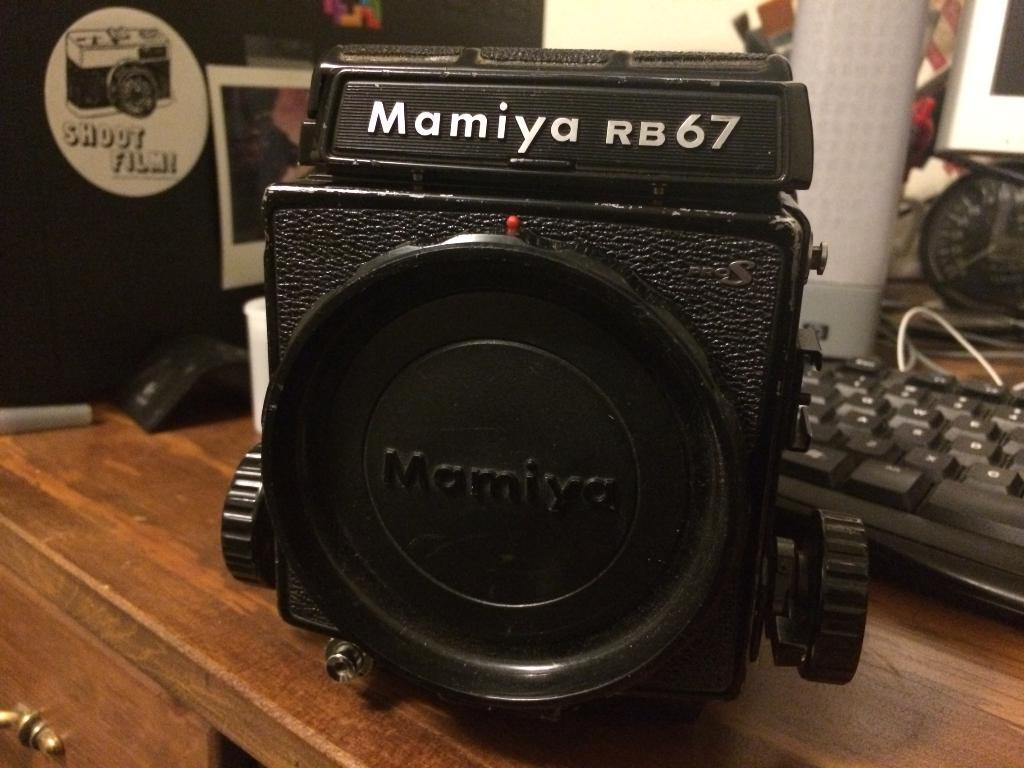<image>
Describe the image concisely. A camera lens showing the model number Mamiya RB67. 